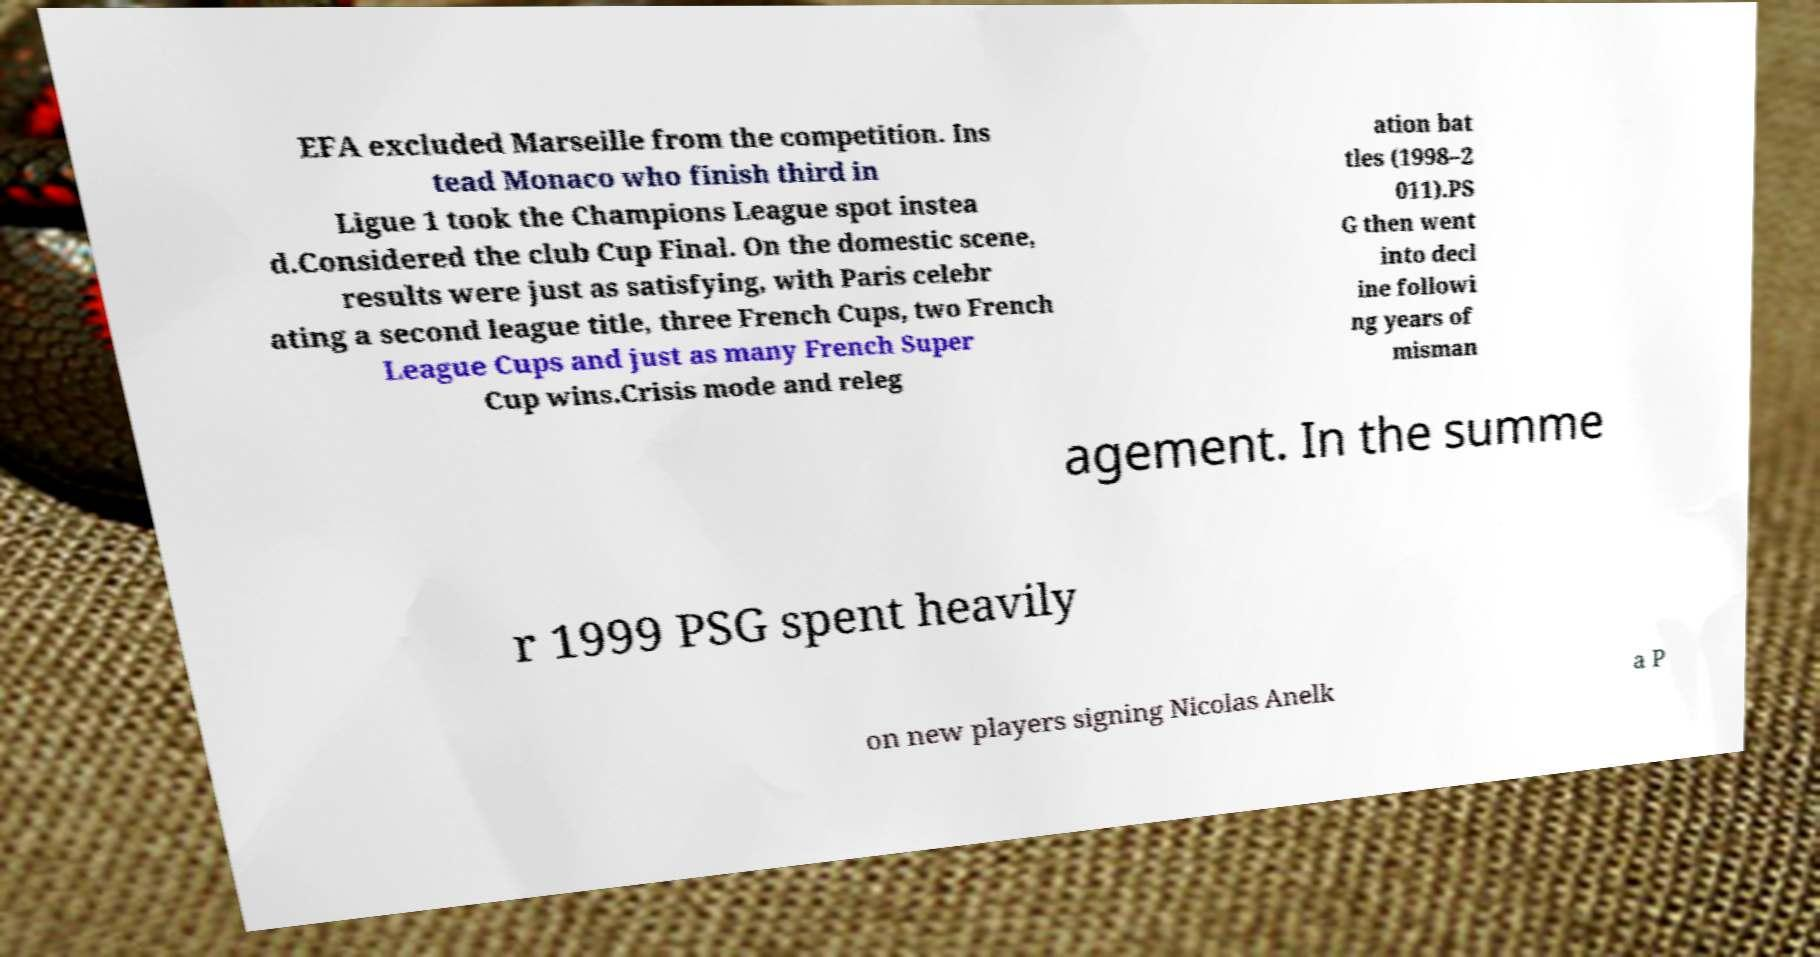Please read and relay the text visible in this image. What does it say? EFA excluded Marseille from the competition. Ins tead Monaco who finish third in Ligue 1 took the Champions League spot instea d.Considered the club Cup Final. On the domestic scene, results were just as satisfying, with Paris celebr ating a second league title, three French Cups, two French League Cups and just as many French Super Cup wins.Crisis mode and releg ation bat tles (1998–2 011).PS G then went into decl ine followi ng years of misman agement. In the summe r 1999 PSG spent heavily on new players signing Nicolas Anelk a P 